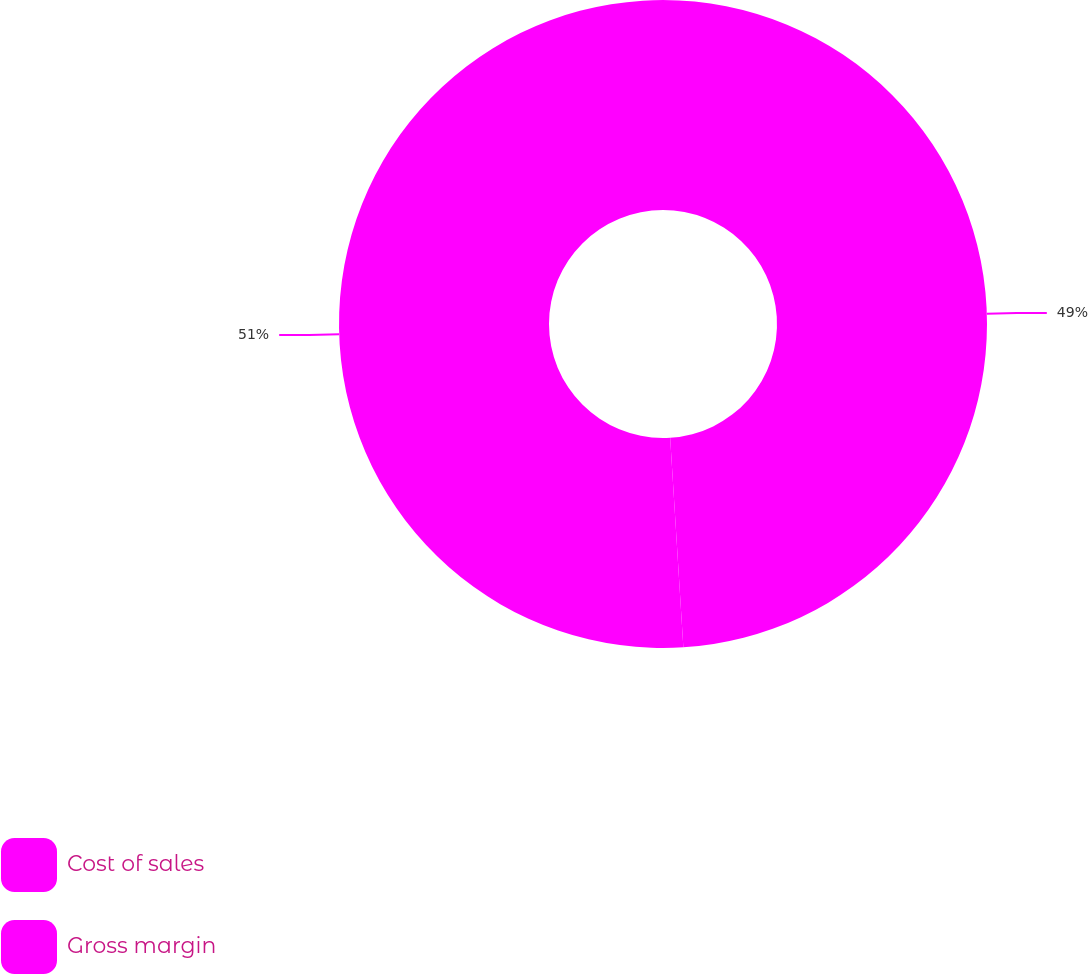Convert chart to OTSL. <chart><loc_0><loc_0><loc_500><loc_500><pie_chart><fcel>Cost of sales<fcel>Gross margin<nl><fcel>49.0%<fcel>51.0%<nl></chart> 